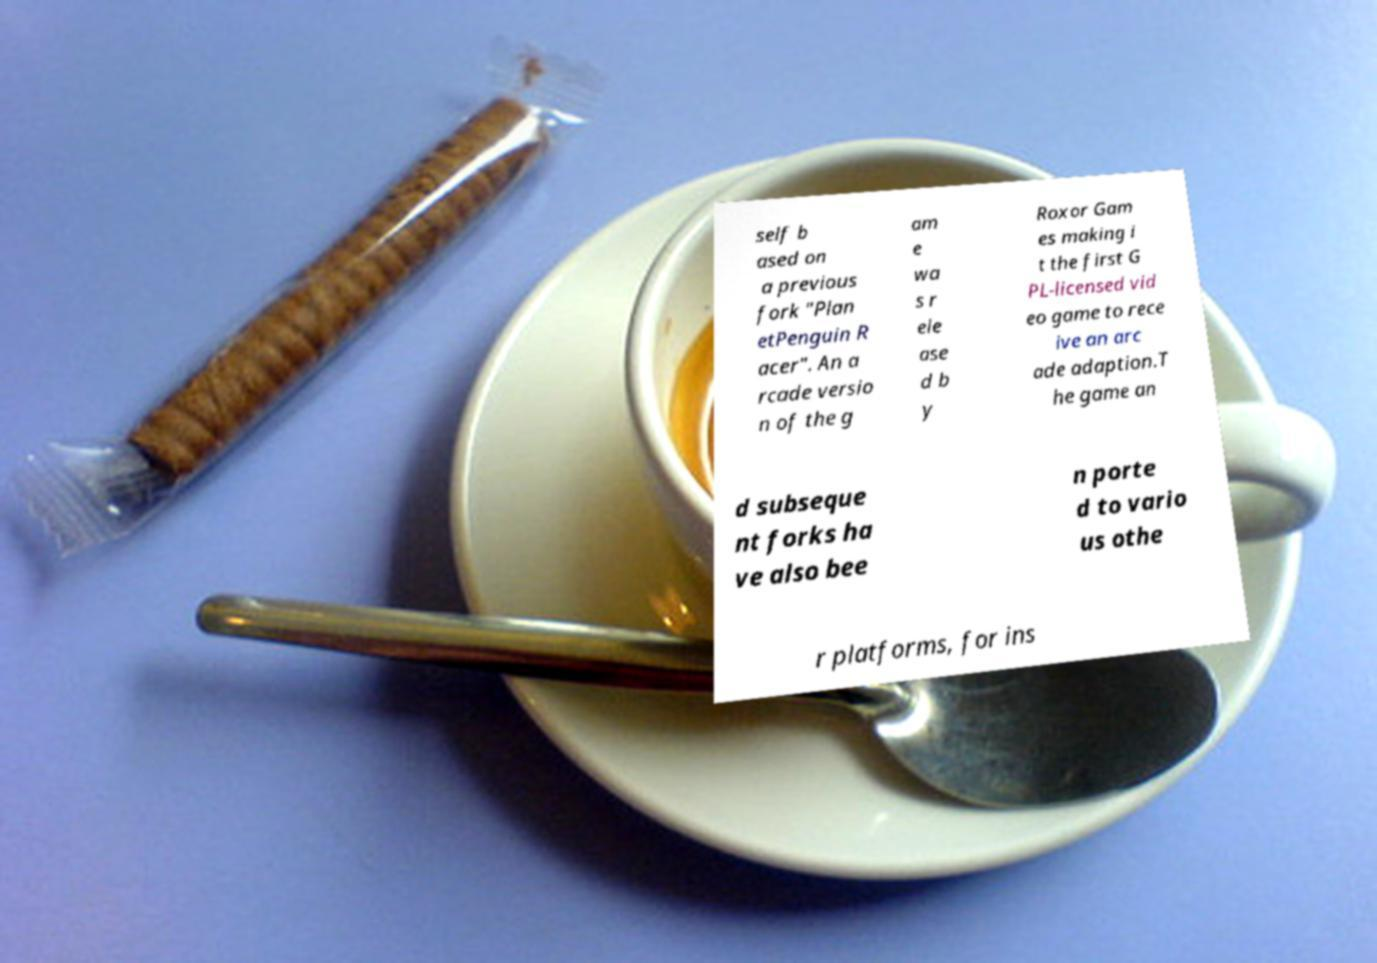For documentation purposes, I need the text within this image transcribed. Could you provide that? self b ased on a previous fork "Plan etPenguin R acer". An a rcade versio n of the g am e wa s r ele ase d b y Roxor Gam es making i t the first G PL-licensed vid eo game to rece ive an arc ade adaption.T he game an d subseque nt forks ha ve also bee n porte d to vario us othe r platforms, for ins 